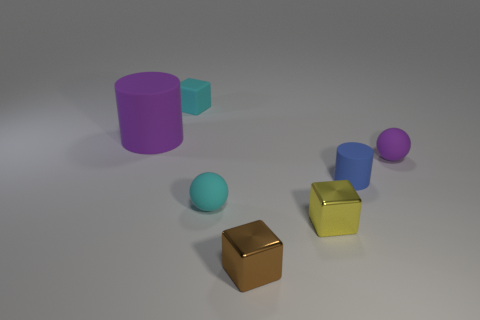How do the shadows in the image inform us about the light source? The shadows are cast to the bottom right of the objects, which suggests that the light source is positioned to the top left of the scene. The softness of the shadows indicates that the light source is not overly intense and is likely diffused. 